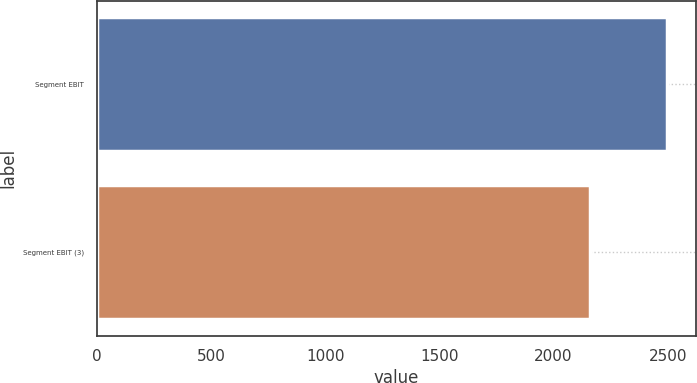Convert chart. <chart><loc_0><loc_0><loc_500><loc_500><bar_chart><fcel>Segment EBIT<fcel>Segment EBIT (3)<nl><fcel>2498<fcel>2160<nl></chart> 